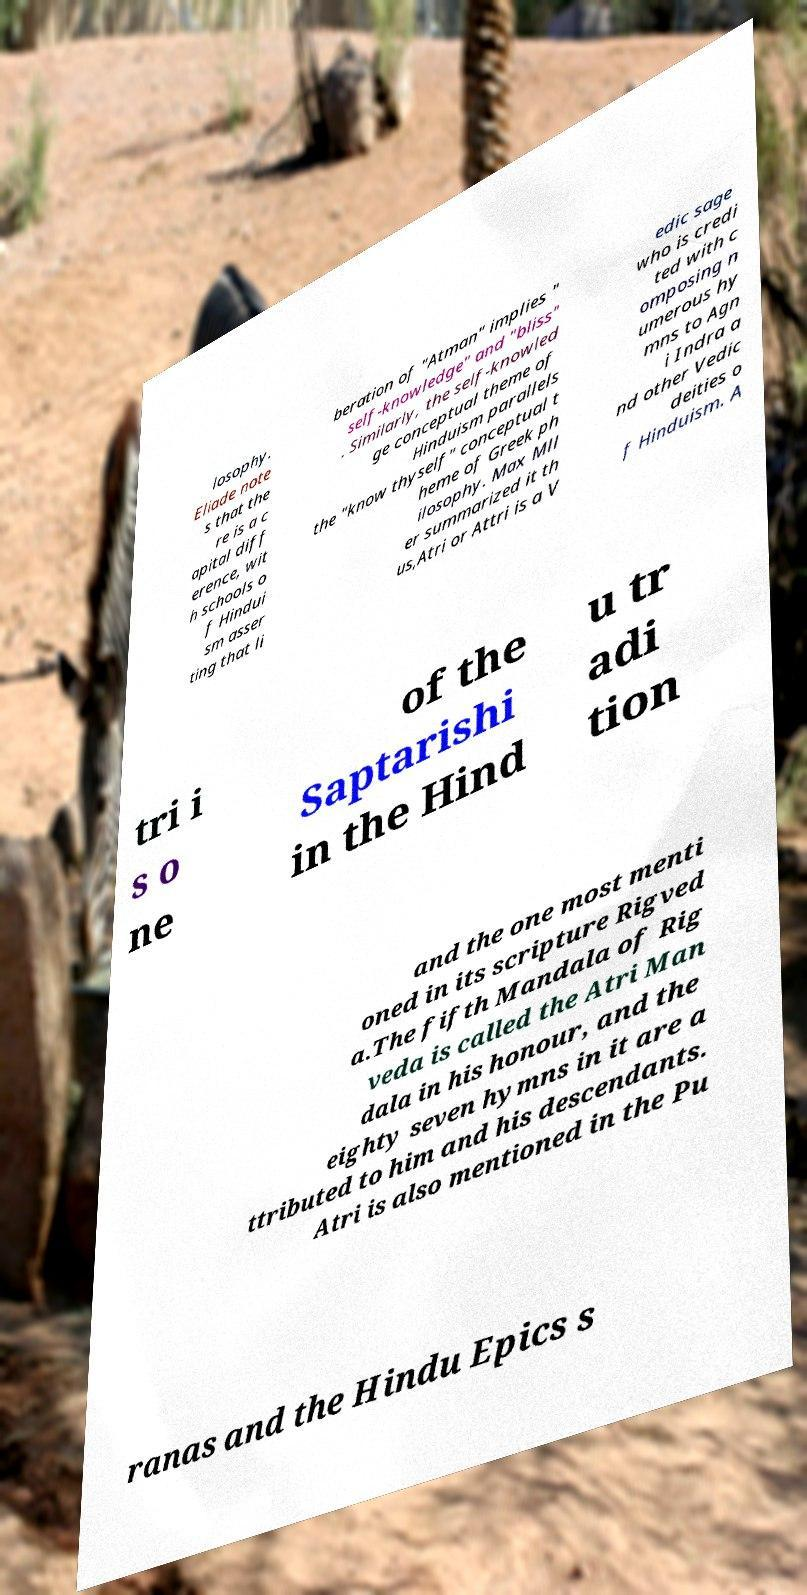For documentation purposes, I need the text within this image transcribed. Could you provide that? losophy. Eliade note s that the re is a c apital diff erence, wit h schools o f Hindui sm asser ting that li beration of "Atman" implies " self-knowledge" and "bliss" . Similarly, the self-knowled ge conceptual theme of Hinduism parallels the "know thyself" conceptual t heme of Greek ph ilosophy. Max Mll er summarized it th us,Atri or Attri is a V edic sage who is credi ted with c omposing n umerous hy mns to Agn i Indra a nd other Vedic deities o f Hinduism. A tri i s o ne of the Saptarishi in the Hind u tr adi tion and the one most menti oned in its scripture Rigved a.The fifth Mandala of Rig veda is called the Atri Man dala in his honour, and the eighty seven hymns in it are a ttributed to him and his descendants. Atri is also mentioned in the Pu ranas and the Hindu Epics s 